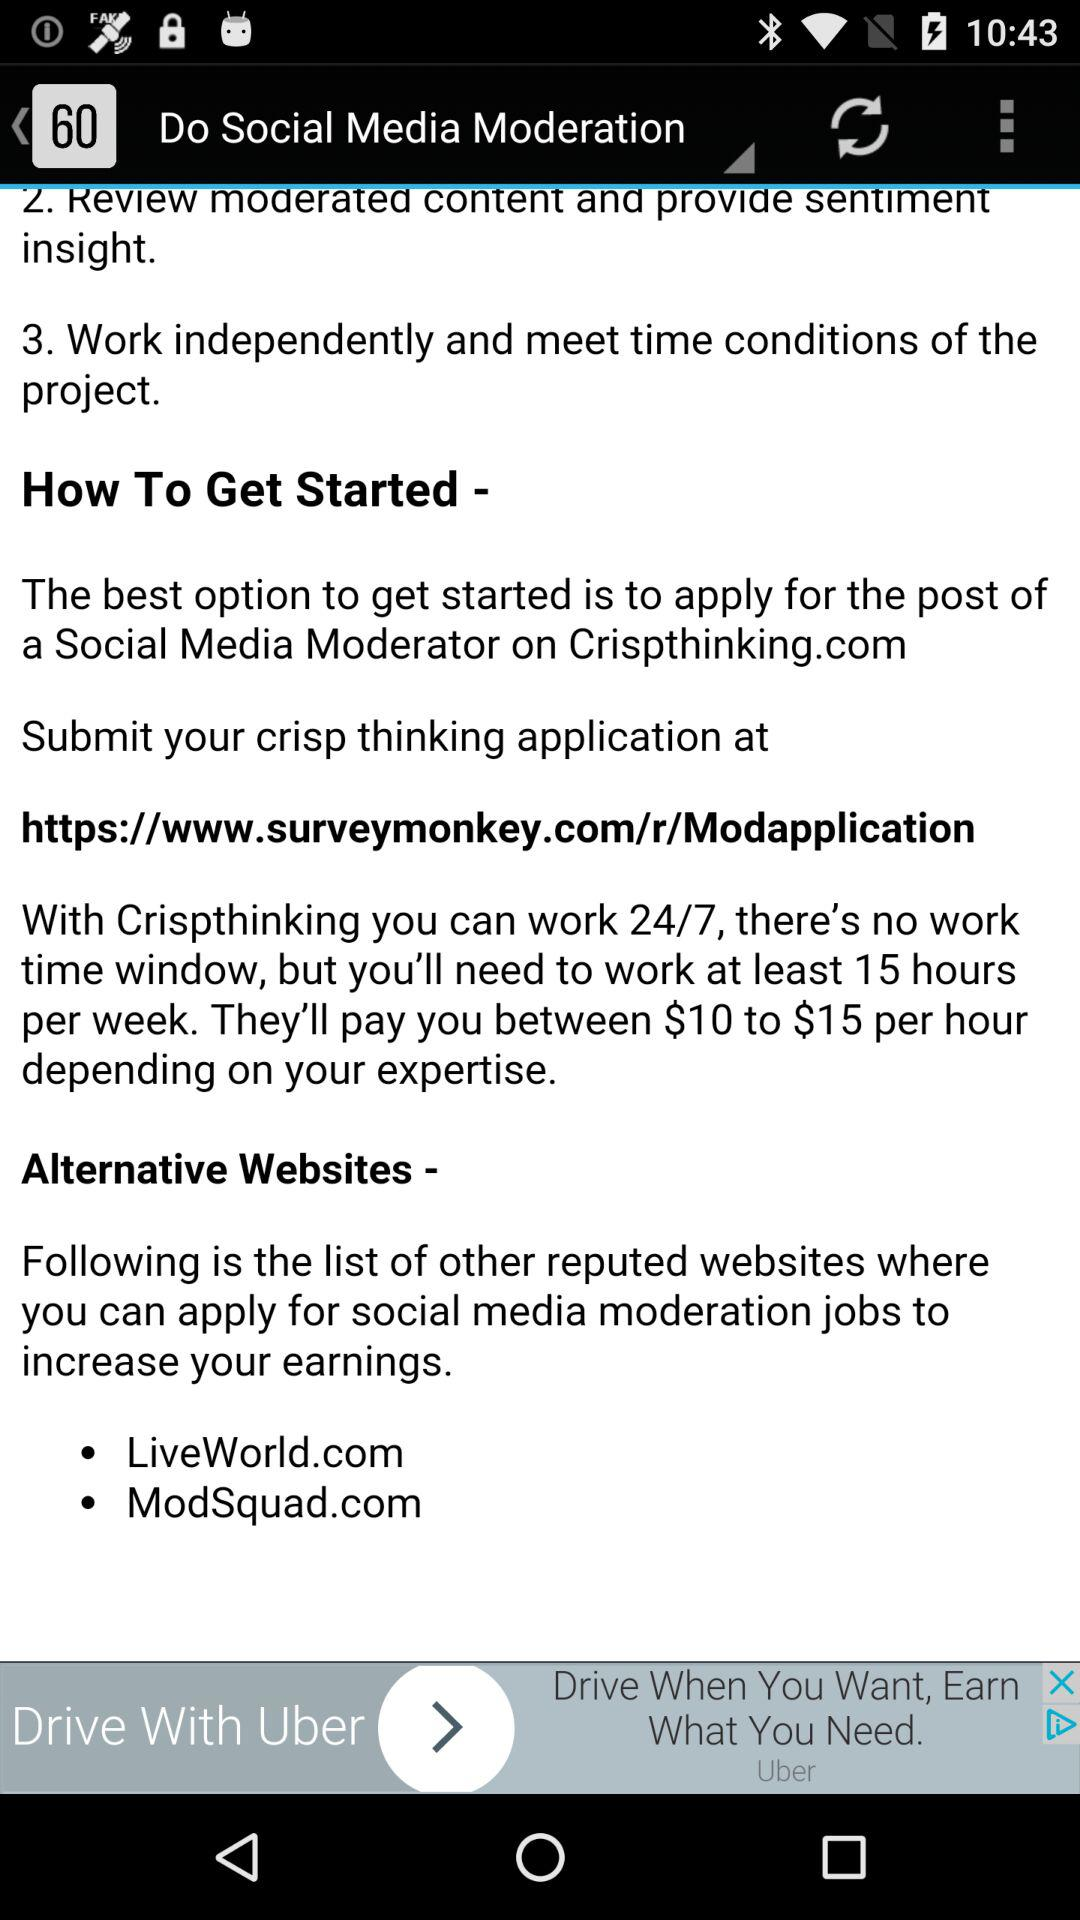How many steps are there in the process of becoming a social media moderator?
Answer the question using a single word or phrase. 3 